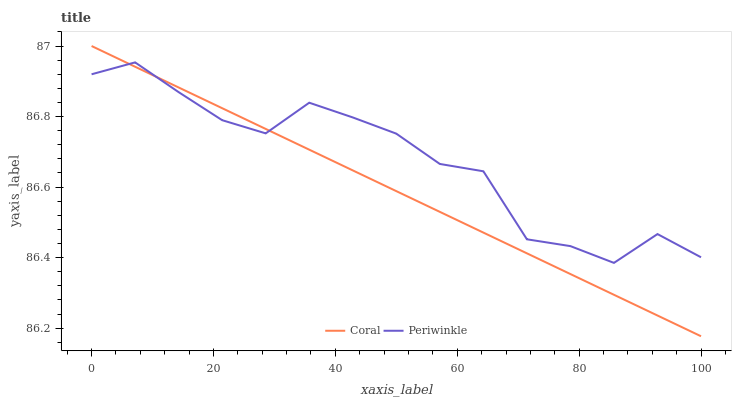Does Coral have the minimum area under the curve?
Answer yes or no. Yes. Does Periwinkle have the maximum area under the curve?
Answer yes or no. Yes. Does Periwinkle have the minimum area under the curve?
Answer yes or no. No. Is Coral the smoothest?
Answer yes or no. Yes. Is Periwinkle the roughest?
Answer yes or no. Yes. Is Periwinkle the smoothest?
Answer yes or no. No. Does Coral have the lowest value?
Answer yes or no. Yes. Does Periwinkle have the lowest value?
Answer yes or no. No. Does Coral have the highest value?
Answer yes or no. Yes. Does Periwinkle have the highest value?
Answer yes or no. No. Does Coral intersect Periwinkle?
Answer yes or no. Yes. Is Coral less than Periwinkle?
Answer yes or no. No. Is Coral greater than Periwinkle?
Answer yes or no. No. 